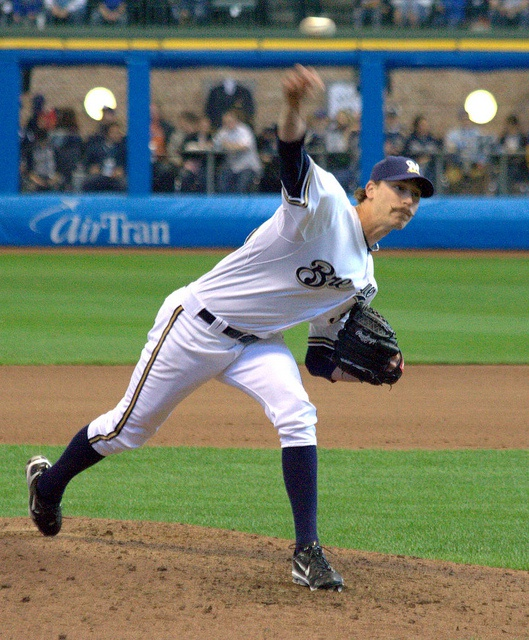Describe the objects in this image and their specific colors. I can see people in gray, lavender, black, and darkgray tones, baseball glove in gray, black, and green tones, people in gray, darkgray, navy, and blue tones, people in gray, black, and purple tones, and people in gray, darkgray, and black tones in this image. 